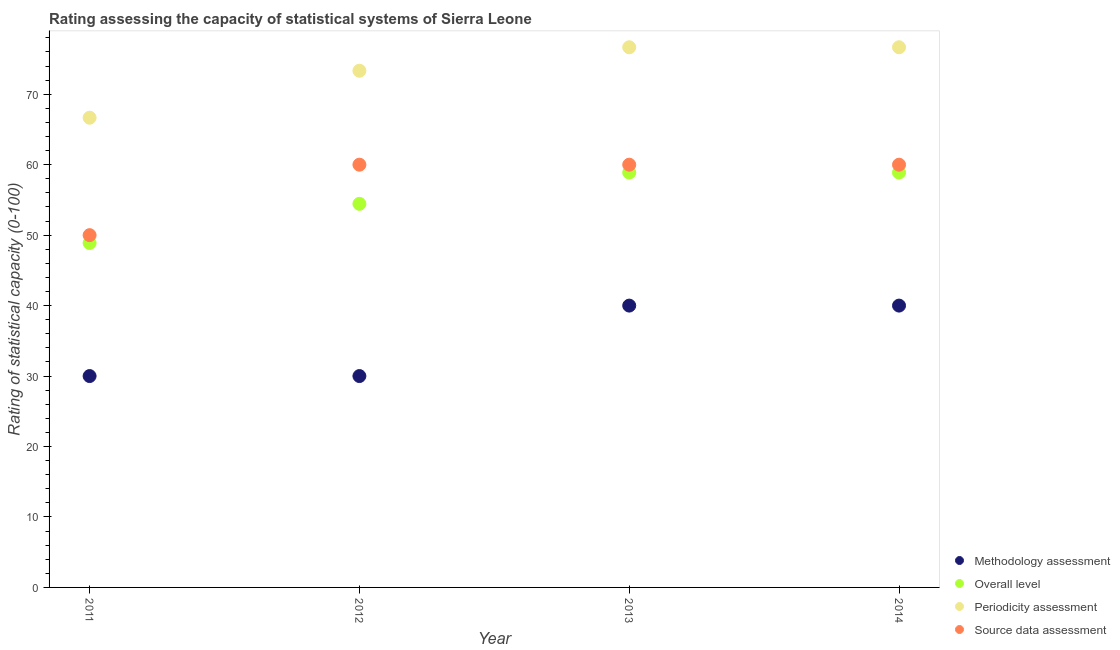What is the periodicity assessment rating in 2014?
Keep it short and to the point. 76.67. Across all years, what is the maximum methodology assessment rating?
Give a very brief answer. 40. Across all years, what is the minimum source data assessment rating?
Offer a terse response. 50. In which year was the methodology assessment rating maximum?
Ensure brevity in your answer.  2013. What is the total periodicity assessment rating in the graph?
Your answer should be very brief. 293.33. What is the difference between the overall level rating in 2013 and the source data assessment rating in 2012?
Offer a very short reply. -1.11. What is the average methodology assessment rating per year?
Ensure brevity in your answer.  35. In the year 2012, what is the difference between the source data assessment rating and methodology assessment rating?
Keep it short and to the point. 30. In how many years, is the source data assessment rating greater than 52?
Provide a succinct answer. 3. What is the ratio of the overall level rating in 2011 to that in 2014?
Provide a succinct answer. 0.83. Is the periodicity assessment rating in 2011 less than that in 2014?
Keep it short and to the point. Yes. What is the difference between the highest and the second highest overall level rating?
Your response must be concise. 0. What is the difference between the highest and the lowest overall level rating?
Offer a very short reply. 10. In how many years, is the source data assessment rating greater than the average source data assessment rating taken over all years?
Offer a terse response. 3. Is the sum of the periodicity assessment rating in 2011 and 2013 greater than the maximum methodology assessment rating across all years?
Provide a short and direct response. Yes. Is it the case that in every year, the sum of the methodology assessment rating and overall level rating is greater than the periodicity assessment rating?
Your answer should be very brief. Yes. Is the overall level rating strictly greater than the source data assessment rating over the years?
Ensure brevity in your answer.  No. How many dotlines are there?
Provide a succinct answer. 4. How many years are there in the graph?
Ensure brevity in your answer.  4. What is the difference between two consecutive major ticks on the Y-axis?
Your answer should be very brief. 10. Does the graph contain any zero values?
Your answer should be compact. No. How many legend labels are there?
Your response must be concise. 4. How are the legend labels stacked?
Provide a short and direct response. Vertical. What is the title of the graph?
Provide a succinct answer. Rating assessing the capacity of statistical systems of Sierra Leone. What is the label or title of the Y-axis?
Your answer should be very brief. Rating of statistical capacity (0-100). What is the Rating of statistical capacity (0-100) in Overall level in 2011?
Make the answer very short. 48.89. What is the Rating of statistical capacity (0-100) in Periodicity assessment in 2011?
Provide a short and direct response. 66.67. What is the Rating of statistical capacity (0-100) of Methodology assessment in 2012?
Your answer should be very brief. 30. What is the Rating of statistical capacity (0-100) in Overall level in 2012?
Keep it short and to the point. 54.44. What is the Rating of statistical capacity (0-100) of Periodicity assessment in 2012?
Give a very brief answer. 73.33. What is the Rating of statistical capacity (0-100) in Methodology assessment in 2013?
Make the answer very short. 40. What is the Rating of statistical capacity (0-100) of Overall level in 2013?
Your answer should be very brief. 58.89. What is the Rating of statistical capacity (0-100) in Periodicity assessment in 2013?
Offer a very short reply. 76.67. What is the Rating of statistical capacity (0-100) of Source data assessment in 2013?
Offer a terse response. 60. What is the Rating of statistical capacity (0-100) of Overall level in 2014?
Give a very brief answer. 58.89. What is the Rating of statistical capacity (0-100) of Periodicity assessment in 2014?
Provide a short and direct response. 76.67. Across all years, what is the maximum Rating of statistical capacity (0-100) in Overall level?
Your answer should be compact. 58.89. Across all years, what is the maximum Rating of statistical capacity (0-100) of Periodicity assessment?
Your answer should be very brief. 76.67. Across all years, what is the minimum Rating of statistical capacity (0-100) of Overall level?
Your answer should be very brief. 48.89. Across all years, what is the minimum Rating of statistical capacity (0-100) in Periodicity assessment?
Provide a short and direct response. 66.67. What is the total Rating of statistical capacity (0-100) in Methodology assessment in the graph?
Your answer should be compact. 140. What is the total Rating of statistical capacity (0-100) of Overall level in the graph?
Offer a terse response. 221.11. What is the total Rating of statistical capacity (0-100) in Periodicity assessment in the graph?
Make the answer very short. 293.33. What is the total Rating of statistical capacity (0-100) of Source data assessment in the graph?
Your answer should be compact. 230. What is the difference between the Rating of statistical capacity (0-100) of Overall level in 2011 and that in 2012?
Ensure brevity in your answer.  -5.56. What is the difference between the Rating of statistical capacity (0-100) in Periodicity assessment in 2011 and that in 2012?
Your answer should be very brief. -6.67. What is the difference between the Rating of statistical capacity (0-100) in Source data assessment in 2011 and that in 2012?
Offer a very short reply. -10. What is the difference between the Rating of statistical capacity (0-100) of Periodicity assessment in 2011 and that in 2013?
Provide a succinct answer. -10. What is the difference between the Rating of statistical capacity (0-100) of Source data assessment in 2011 and that in 2013?
Provide a succinct answer. -10. What is the difference between the Rating of statistical capacity (0-100) in Overall level in 2011 and that in 2014?
Your answer should be compact. -10. What is the difference between the Rating of statistical capacity (0-100) of Periodicity assessment in 2011 and that in 2014?
Give a very brief answer. -10. What is the difference between the Rating of statistical capacity (0-100) of Source data assessment in 2011 and that in 2014?
Your answer should be very brief. -10. What is the difference between the Rating of statistical capacity (0-100) of Methodology assessment in 2012 and that in 2013?
Ensure brevity in your answer.  -10. What is the difference between the Rating of statistical capacity (0-100) in Overall level in 2012 and that in 2013?
Ensure brevity in your answer.  -4.44. What is the difference between the Rating of statistical capacity (0-100) of Periodicity assessment in 2012 and that in 2013?
Your answer should be very brief. -3.33. What is the difference between the Rating of statistical capacity (0-100) of Source data assessment in 2012 and that in 2013?
Offer a very short reply. 0. What is the difference between the Rating of statistical capacity (0-100) in Methodology assessment in 2012 and that in 2014?
Make the answer very short. -10. What is the difference between the Rating of statistical capacity (0-100) in Overall level in 2012 and that in 2014?
Provide a succinct answer. -4.44. What is the difference between the Rating of statistical capacity (0-100) of Methodology assessment in 2011 and the Rating of statistical capacity (0-100) of Overall level in 2012?
Offer a very short reply. -24.44. What is the difference between the Rating of statistical capacity (0-100) of Methodology assessment in 2011 and the Rating of statistical capacity (0-100) of Periodicity assessment in 2012?
Make the answer very short. -43.33. What is the difference between the Rating of statistical capacity (0-100) in Methodology assessment in 2011 and the Rating of statistical capacity (0-100) in Source data assessment in 2012?
Provide a succinct answer. -30. What is the difference between the Rating of statistical capacity (0-100) of Overall level in 2011 and the Rating of statistical capacity (0-100) of Periodicity assessment in 2012?
Your answer should be very brief. -24.44. What is the difference between the Rating of statistical capacity (0-100) in Overall level in 2011 and the Rating of statistical capacity (0-100) in Source data assessment in 2012?
Your response must be concise. -11.11. What is the difference between the Rating of statistical capacity (0-100) in Methodology assessment in 2011 and the Rating of statistical capacity (0-100) in Overall level in 2013?
Your answer should be very brief. -28.89. What is the difference between the Rating of statistical capacity (0-100) of Methodology assessment in 2011 and the Rating of statistical capacity (0-100) of Periodicity assessment in 2013?
Your answer should be compact. -46.67. What is the difference between the Rating of statistical capacity (0-100) of Overall level in 2011 and the Rating of statistical capacity (0-100) of Periodicity assessment in 2013?
Make the answer very short. -27.78. What is the difference between the Rating of statistical capacity (0-100) in Overall level in 2011 and the Rating of statistical capacity (0-100) in Source data assessment in 2013?
Make the answer very short. -11.11. What is the difference between the Rating of statistical capacity (0-100) in Methodology assessment in 2011 and the Rating of statistical capacity (0-100) in Overall level in 2014?
Keep it short and to the point. -28.89. What is the difference between the Rating of statistical capacity (0-100) of Methodology assessment in 2011 and the Rating of statistical capacity (0-100) of Periodicity assessment in 2014?
Keep it short and to the point. -46.67. What is the difference between the Rating of statistical capacity (0-100) in Methodology assessment in 2011 and the Rating of statistical capacity (0-100) in Source data assessment in 2014?
Your response must be concise. -30. What is the difference between the Rating of statistical capacity (0-100) in Overall level in 2011 and the Rating of statistical capacity (0-100) in Periodicity assessment in 2014?
Your response must be concise. -27.78. What is the difference between the Rating of statistical capacity (0-100) in Overall level in 2011 and the Rating of statistical capacity (0-100) in Source data assessment in 2014?
Your answer should be very brief. -11.11. What is the difference between the Rating of statistical capacity (0-100) in Periodicity assessment in 2011 and the Rating of statistical capacity (0-100) in Source data assessment in 2014?
Your answer should be compact. 6.67. What is the difference between the Rating of statistical capacity (0-100) in Methodology assessment in 2012 and the Rating of statistical capacity (0-100) in Overall level in 2013?
Provide a succinct answer. -28.89. What is the difference between the Rating of statistical capacity (0-100) in Methodology assessment in 2012 and the Rating of statistical capacity (0-100) in Periodicity assessment in 2013?
Offer a very short reply. -46.67. What is the difference between the Rating of statistical capacity (0-100) of Methodology assessment in 2012 and the Rating of statistical capacity (0-100) of Source data assessment in 2013?
Offer a terse response. -30. What is the difference between the Rating of statistical capacity (0-100) in Overall level in 2012 and the Rating of statistical capacity (0-100) in Periodicity assessment in 2013?
Your answer should be compact. -22.22. What is the difference between the Rating of statistical capacity (0-100) of Overall level in 2012 and the Rating of statistical capacity (0-100) of Source data assessment in 2013?
Give a very brief answer. -5.56. What is the difference between the Rating of statistical capacity (0-100) of Periodicity assessment in 2012 and the Rating of statistical capacity (0-100) of Source data assessment in 2013?
Your answer should be compact. 13.33. What is the difference between the Rating of statistical capacity (0-100) of Methodology assessment in 2012 and the Rating of statistical capacity (0-100) of Overall level in 2014?
Ensure brevity in your answer.  -28.89. What is the difference between the Rating of statistical capacity (0-100) in Methodology assessment in 2012 and the Rating of statistical capacity (0-100) in Periodicity assessment in 2014?
Provide a succinct answer. -46.67. What is the difference between the Rating of statistical capacity (0-100) in Methodology assessment in 2012 and the Rating of statistical capacity (0-100) in Source data assessment in 2014?
Offer a terse response. -30. What is the difference between the Rating of statistical capacity (0-100) in Overall level in 2012 and the Rating of statistical capacity (0-100) in Periodicity assessment in 2014?
Offer a terse response. -22.22. What is the difference between the Rating of statistical capacity (0-100) of Overall level in 2012 and the Rating of statistical capacity (0-100) of Source data assessment in 2014?
Your answer should be compact. -5.56. What is the difference between the Rating of statistical capacity (0-100) of Periodicity assessment in 2012 and the Rating of statistical capacity (0-100) of Source data assessment in 2014?
Your answer should be very brief. 13.33. What is the difference between the Rating of statistical capacity (0-100) in Methodology assessment in 2013 and the Rating of statistical capacity (0-100) in Overall level in 2014?
Your answer should be compact. -18.89. What is the difference between the Rating of statistical capacity (0-100) of Methodology assessment in 2013 and the Rating of statistical capacity (0-100) of Periodicity assessment in 2014?
Keep it short and to the point. -36.67. What is the difference between the Rating of statistical capacity (0-100) in Overall level in 2013 and the Rating of statistical capacity (0-100) in Periodicity assessment in 2014?
Provide a succinct answer. -17.78. What is the difference between the Rating of statistical capacity (0-100) in Overall level in 2013 and the Rating of statistical capacity (0-100) in Source data assessment in 2014?
Offer a very short reply. -1.11. What is the difference between the Rating of statistical capacity (0-100) of Periodicity assessment in 2013 and the Rating of statistical capacity (0-100) of Source data assessment in 2014?
Make the answer very short. 16.67. What is the average Rating of statistical capacity (0-100) in Overall level per year?
Make the answer very short. 55.28. What is the average Rating of statistical capacity (0-100) of Periodicity assessment per year?
Make the answer very short. 73.33. What is the average Rating of statistical capacity (0-100) of Source data assessment per year?
Offer a terse response. 57.5. In the year 2011, what is the difference between the Rating of statistical capacity (0-100) in Methodology assessment and Rating of statistical capacity (0-100) in Overall level?
Your answer should be compact. -18.89. In the year 2011, what is the difference between the Rating of statistical capacity (0-100) of Methodology assessment and Rating of statistical capacity (0-100) of Periodicity assessment?
Your response must be concise. -36.67. In the year 2011, what is the difference between the Rating of statistical capacity (0-100) in Methodology assessment and Rating of statistical capacity (0-100) in Source data assessment?
Provide a short and direct response. -20. In the year 2011, what is the difference between the Rating of statistical capacity (0-100) in Overall level and Rating of statistical capacity (0-100) in Periodicity assessment?
Provide a succinct answer. -17.78. In the year 2011, what is the difference between the Rating of statistical capacity (0-100) of Overall level and Rating of statistical capacity (0-100) of Source data assessment?
Keep it short and to the point. -1.11. In the year 2011, what is the difference between the Rating of statistical capacity (0-100) of Periodicity assessment and Rating of statistical capacity (0-100) of Source data assessment?
Make the answer very short. 16.67. In the year 2012, what is the difference between the Rating of statistical capacity (0-100) of Methodology assessment and Rating of statistical capacity (0-100) of Overall level?
Keep it short and to the point. -24.44. In the year 2012, what is the difference between the Rating of statistical capacity (0-100) in Methodology assessment and Rating of statistical capacity (0-100) in Periodicity assessment?
Your response must be concise. -43.33. In the year 2012, what is the difference between the Rating of statistical capacity (0-100) in Overall level and Rating of statistical capacity (0-100) in Periodicity assessment?
Provide a succinct answer. -18.89. In the year 2012, what is the difference between the Rating of statistical capacity (0-100) of Overall level and Rating of statistical capacity (0-100) of Source data assessment?
Offer a very short reply. -5.56. In the year 2012, what is the difference between the Rating of statistical capacity (0-100) of Periodicity assessment and Rating of statistical capacity (0-100) of Source data assessment?
Ensure brevity in your answer.  13.33. In the year 2013, what is the difference between the Rating of statistical capacity (0-100) of Methodology assessment and Rating of statistical capacity (0-100) of Overall level?
Your answer should be compact. -18.89. In the year 2013, what is the difference between the Rating of statistical capacity (0-100) of Methodology assessment and Rating of statistical capacity (0-100) of Periodicity assessment?
Keep it short and to the point. -36.67. In the year 2013, what is the difference between the Rating of statistical capacity (0-100) in Methodology assessment and Rating of statistical capacity (0-100) in Source data assessment?
Your response must be concise. -20. In the year 2013, what is the difference between the Rating of statistical capacity (0-100) of Overall level and Rating of statistical capacity (0-100) of Periodicity assessment?
Your response must be concise. -17.78. In the year 2013, what is the difference between the Rating of statistical capacity (0-100) in Overall level and Rating of statistical capacity (0-100) in Source data assessment?
Offer a terse response. -1.11. In the year 2013, what is the difference between the Rating of statistical capacity (0-100) of Periodicity assessment and Rating of statistical capacity (0-100) of Source data assessment?
Make the answer very short. 16.67. In the year 2014, what is the difference between the Rating of statistical capacity (0-100) of Methodology assessment and Rating of statistical capacity (0-100) of Overall level?
Provide a succinct answer. -18.89. In the year 2014, what is the difference between the Rating of statistical capacity (0-100) in Methodology assessment and Rating of statistical capacity (0-100) in Periodicity assessment?
Your answer should be very brief. -36.67. In the year 2014, what is the difference between the Rating of statistical capacity (0-100) in Overall level and Rating of statistical capacity (0-100) in Periodicity assessment?
Give a very brief answer. -17.78. In the year 2014, what is the difference between the Rating of statistical capacity (0-100) in Overall level and Rating of statistical capacity (0-100) in Source data assessment?
Your response must be concise. -1.11. In the year 2014, what is the difference between the Rating of statistical capacity (0-100) in Periodicity assessment and Rating of statistical capacity (0-100) in Source data assessment?
Provide a succinct answer. 16.67. What is the ratio of the Rating of statistical capacity (0-100) in Methodology assessment in 2011 to that in 2012?
Provide a short and direct response. 1. What is the ratio of the Rating of statistical capacity (0-100) of Overall level in 2011 to that in 2012?
Provide a succinct answer. 0.9. What is the ratio of the Rating of statistical capacity (0-100) of Periodicity assessment in 2011 to that in 2012?
Give a very brief answer. 0.91. What is the ratio of the Rating of statistical capacity (0-100) of Source data assessment in 2011 to that in 2012?
Provide a short and direct response. 0.83. What is the ratio of the Rating of statistical capacity (0-100) in Overall level in 2011 to that in 2013?
Keep it short and to the point. 0.83. What is the ratio of the Rating of statistical capacity (0-100) of Periodicity assessment in 2011 to that in 2013?
Ensure brevity in your answer.  0.87. What is the ratio of the Rating of statistical capacity (0-100) of Overall level in 2011 to that in 2014?
Offer a very short reply. 0.83. What is the ratio of the Rating of statistical capacity (0-100) in Periodicity assessment in 2011 to that in 2014?
Make the answer very short. 0.87. What is the ratio of the Rating of statistical capacity (0-100) in Methodology assessment in 2012 to that in 2013?
Your answer should be very brief. 0.75. What is the ratio of the Rating of statistical capacity (0-100) of Overall level in 2012 to that in 2013?
Give a very brief answer. 0.92. What is the ratio of the Rating of statistical capacity (0-100) in Periodicity assessment in 2012 to that in 2013?
Your answer should be very brief. 0.96. What is the ratio of the Rating of statistical capacity (0-100) in Overall level in 2012 to that in 2014?
Offer a terse response. 0.92. What is the ratio of the Rating of statistical capacity (0-100) of Periodicity assessment in 2012 to that in 2014?
Offer a terse response. 0.96. What is the ratio of the Rating of statistical capacity (0-100) of Source data assessment in 2012 to that in 2014?
Provide a short and direct response. 1. What is the ratio of the Rating of statistical capacity (0-100) of Periodicity assessment in 2013 to that in 2014?
Ensure brevity in your answer.  1. What is the ratio of the Rating of statistical capacity (0-100) of Source data assessment in 2013 to that in 2014?
Ensure brevity in your answer.  1. What is the difference between the highest and the second highest Rating of statistical capacity (0-100) of Methodology assessment?
Give a very brief answer. 0. What is the difference between the highest and the second highest Rating of statistical capacity (0-100) of Periodicity assessment?
Ensure brevity in your answer.  0. What is the difference between the highest and the second highest Rating of statistical capacity (0-100) of Source data assessment?
Your answer should be compact. 0. What is the difference between the highest and the lowest Rating of statistical capacity (0-100) in Overall level?
Give a very brief answer. 10. What is the difference between the highest and the lowest Rating of statistical capacity (0-100) in Periodicity assessment?
Offer a very short reply. 10. What is the difference between the highest and the lowest Rating of statistical capacity (0-100) in Source data assessment?
Ensure brevity in your answer.  10. 